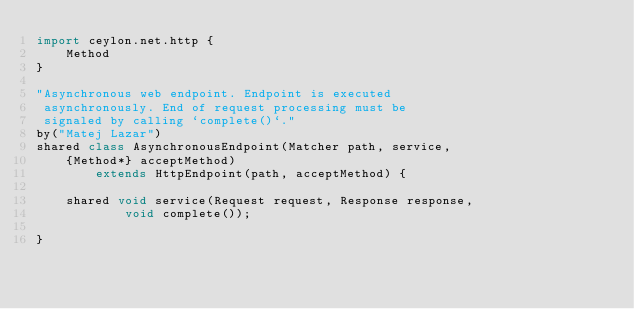<code> <loc_0><loc_0><loc_500><loc_500><_Ceylon_>import ceylon.net.http {
    Method
}

"Asynchronous web endpoint. Endpoint is executed 
 asynchronously. End of request processing must be 
 signaled by calling `complete()`."
by("Matej Lazar")
shared class AsynchronousEndpoint(Matcher path, service, 
    {Method*} acceptMethod) 
        extends HttpEndpoint(path, acceptMethod) {
    
    shared void service(Request request, Response response,
            void complete());
    
}</code> 